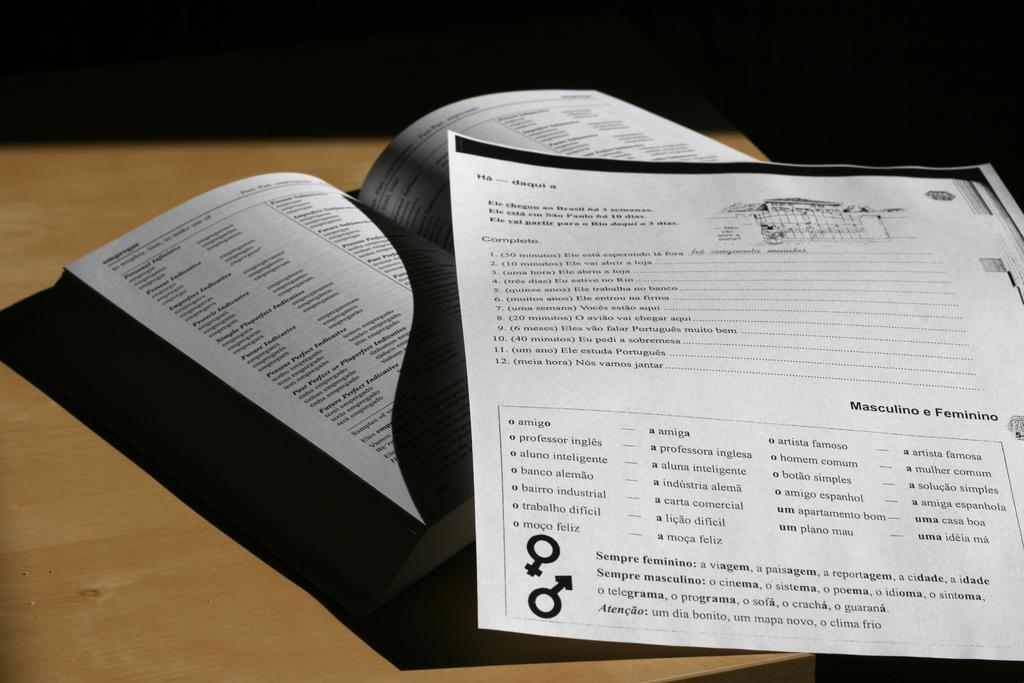<image>
Create a compact narrative representing the image presented. DOUCUMENT PAPER PLACED ON TOP OF THE PAGES OF AN OPEN BOOK 